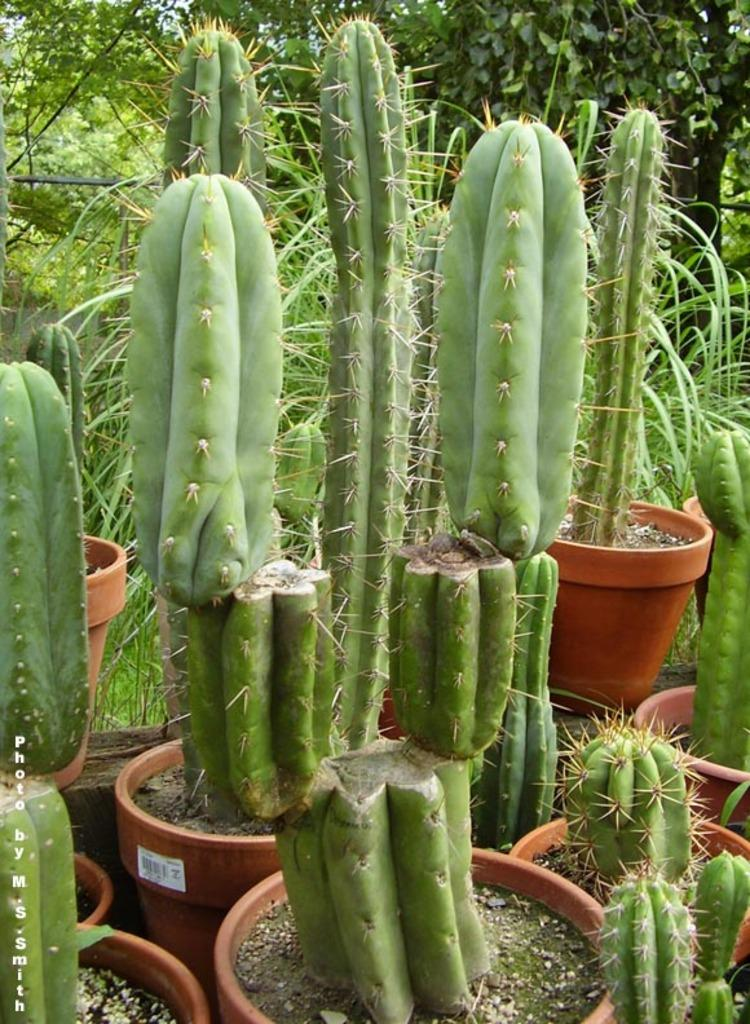What objects are present in the image? There are pots in the image. What is inside the pots? The pots contain cactus plants. What can be seen in the background of the image? There are trees and plants in the background of the image. Are there any fairies playing basketball in the image? No, there are no fairies or basketball present in the image. 